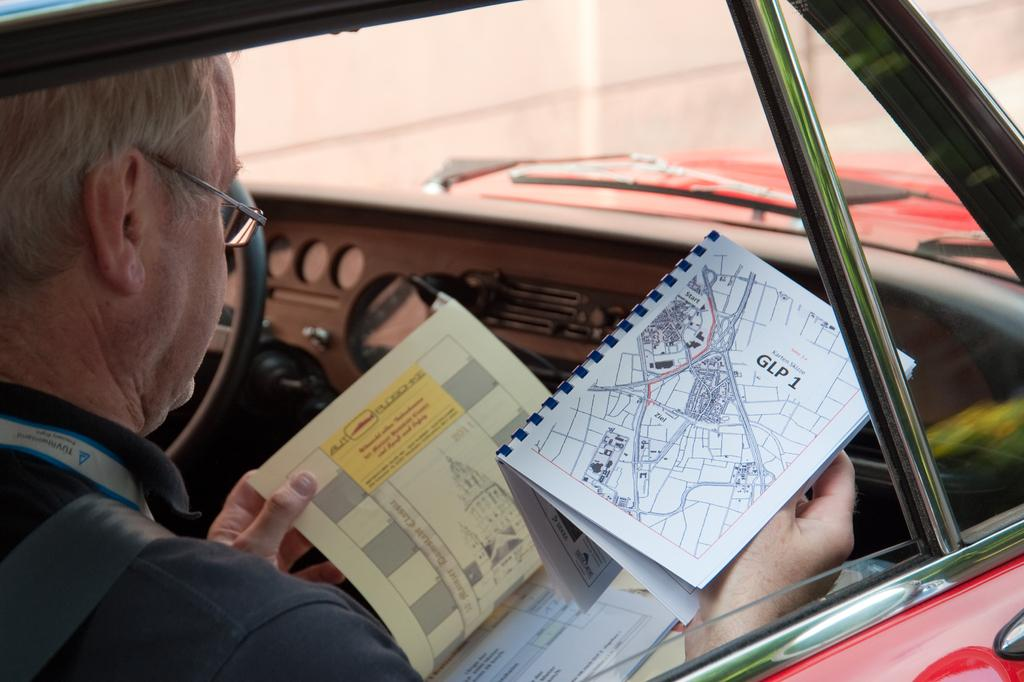What is the man doing inside the vehicle? The man is sitting inside the vehicle. What is the man holding in his hands? The man is holding books. What can be seen through the windscreen of the vehicle? There is a wall visible through the windscreen of the vehicle. What type of floor can be seen in the image? There is no floor visible in the image, as the man is sitting inside a vehicle. 